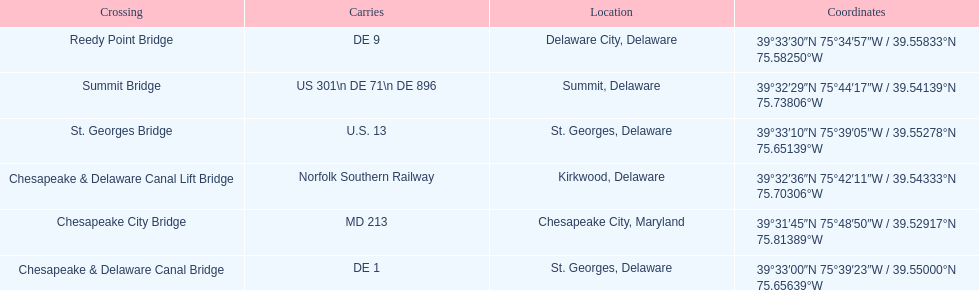How many crossings are in maryland? 1. Can you parse all the data within this table? {'header': ['Crossing', 'Carries', 'Location', 'Coordinates'], 'rows': [['Reedy Point Bridge', 'DE\xa09', 'Delaware City, Delaware', '39°33′30″N 75°34′57″W\ufeff / \ufeff39.55833°N 75.58250°W'], ['Summit Bridge', 'US 301\\n DE 71\\n DE 896', 'Summit, Delaware', '39°32′29″N 75°44′17″W\ufeff / \ufeff39.54139°N 75.73806°W'], ['St.\xa0Georges Bridge', 'U.S.\xa013', 'St.\xa0Georges, Delaware', '39°33′10″N 75°39′05″W\ufeff / \ufeff39.55278°N 75.65139°W'], ['Chesapeake & Delaware Canal Lift Bridge', 'Norfolk Southern Railway', 'Kirkwood, Delaware', '39°32′36″N 75°42′11″W\ufeff / \ufeff39.54333°N 75.70306°W'], ['Chesapeake City Bridge', 'MD 213', 'Chesapeake City, Maryland', '39°31′45″N 75°48′50″W\ufeff / \ufeff39.52917°N 75.81389°W'], ['Chesapeake & Delaware Canal Bridge', 'DE 1', 'St.\xa0Georges, Delaware', '39°33′00″N 75°39′23″W\ufeff / \ufeff39.55000°N 75.65639°W']]} 